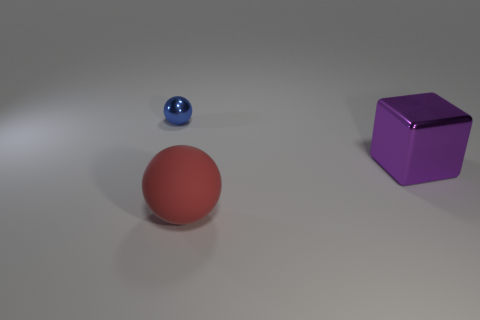Are there fewer tiny yellow shiny things than large purple shiny things?
Provide a succinct answer. Yes. Do the sphere behind the large red sphere and the matte ball have the same color?
Provide a short and direct response. No. What number of blue metallic objects are in front of the shiny object in front of the metal thing on the left side of the big purple metal object?
Keep it short and to the point. 0. There is a large red sphere; how many purple objects are in front of it?
Your response must be concise. 0. What color is the big matte thing that is the same shape as the blue metallic object?
Make the answer very short. Red. There is a object that is on the left side of the large cube and behind the red matte ball; what material is it?
Your response must be concise. Metal. There is a shiny object that is behind the metal block; is its size the same as the red object?
Provide a succinct answer. No. What material is the big red ball?
Your response must be concise. Rubber. What color is the big thing to the left of the purple cube?
Offer a very short reply. Red. How many tiny things are rubber spheres or green things?
Provide a short and direct response. 0. 